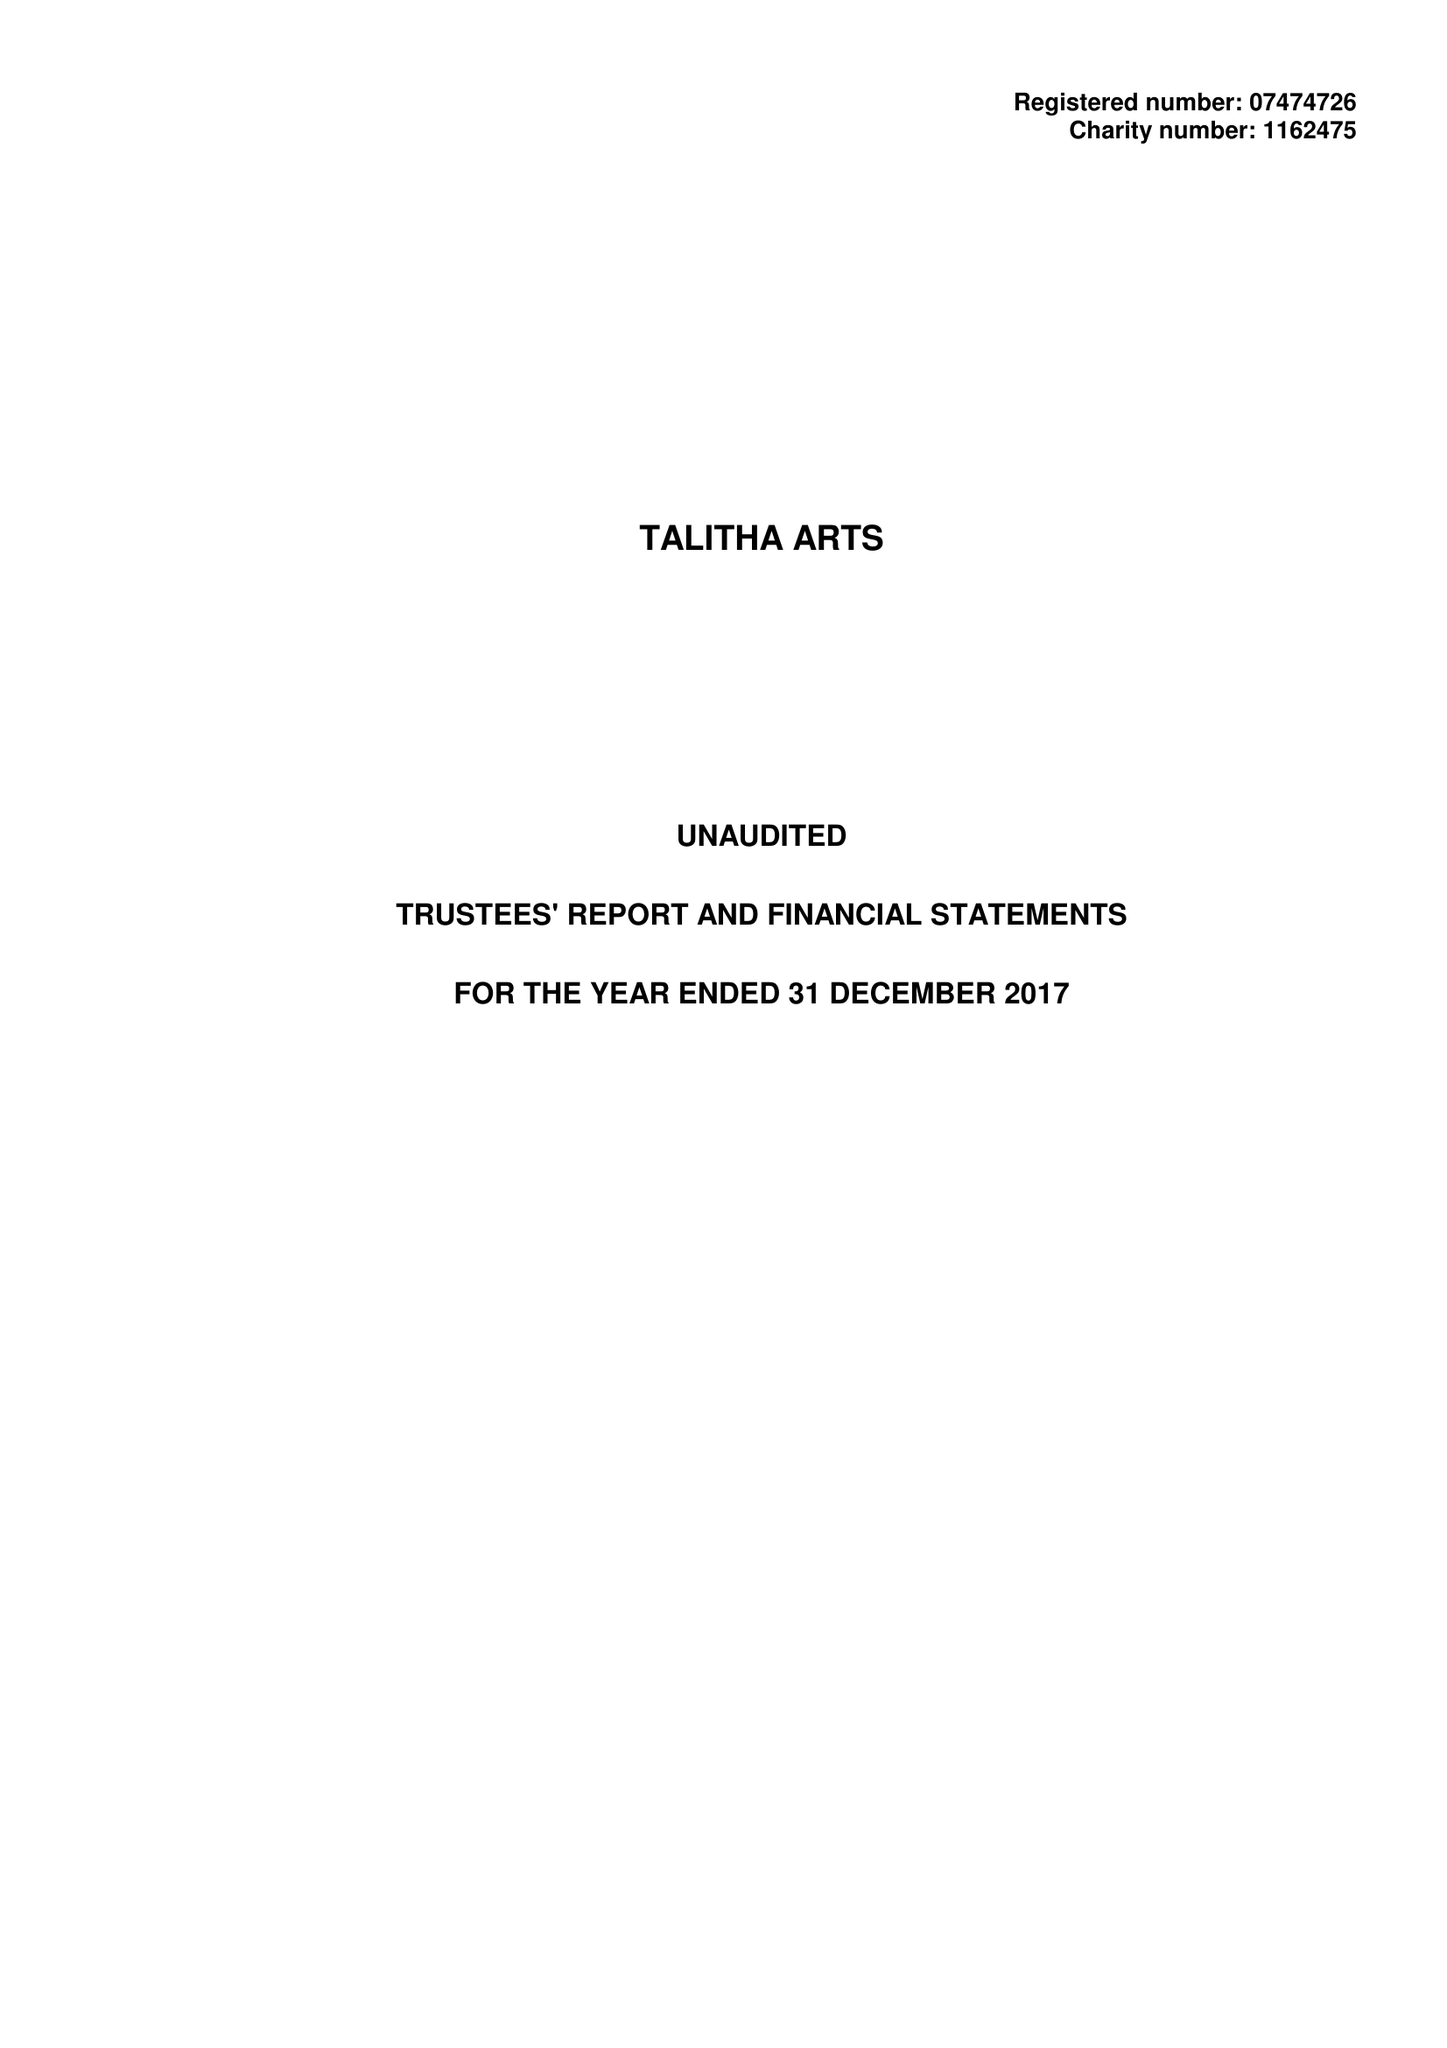What is the value for the income_annually_in_british_pounds?
Answer the question using a single word or phrase. 70810.00 